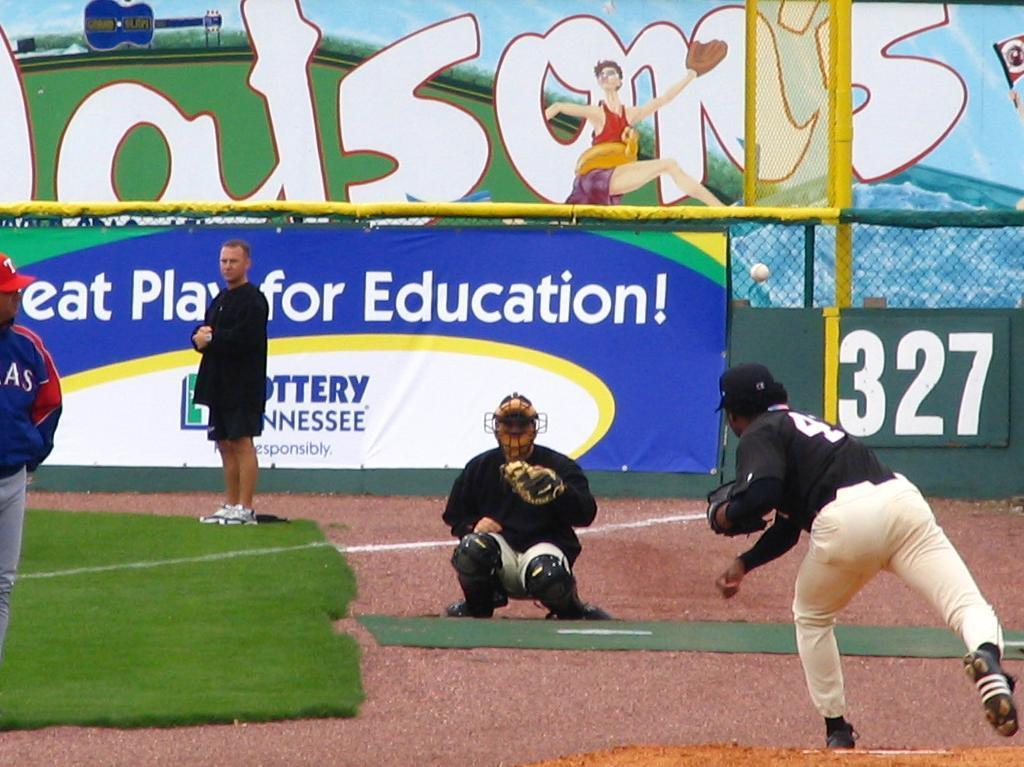<image>
Summarize the visual content of the image. A pitcher warming up with a catcher near a sign that reads in part Play for Education!. 